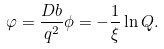<formula> <loc_0><loc_0><loc_500><loc_500>\varphi = \frac { D b } { q ^ { 2 } } \phi = - \frac { 1 } { \xi } \ln Q .</formula> 